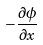Convert formula to latex. <formula><loc_0><loc_0><loc_500><loc_500>- \frac { \partial \phi } { \partial x }</formula> 